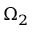Convert formula to latex. <formula><loc_0><loc_0><loc_500><loc_500>\Omega _ { 2 }</formula> 